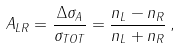Convert formula to latex. <formula><loc_0><loc_0><loc_500><loc_500>A _ { L R } = \frac { \Delta \sigma _ { A } } { \sigma _ { T O T } } = \frac { n _ { L } - n _ { R } } { n _ { L } + n _ { R } } \, ,</formula> 